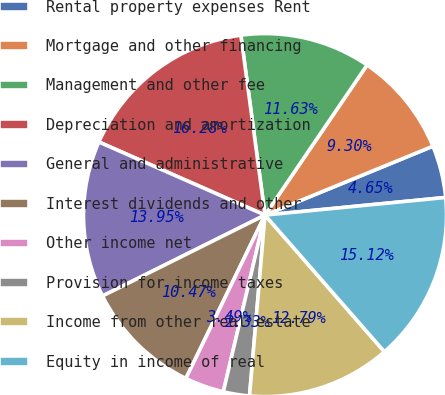<chart> <loc_0><loc_0><loc_500><loc_500><pie_chart><fcel>Rental property expenses Rent<fcel>Mortgage and other financing<fcel>Management and other fee<fcel>Depreciation and amortization<fcel>General and administrative<fcel>Interest dividends and other<fcel>Other income net<fcel>Provision for income taxes<fcel>Income from other real estate<fcel>Equity in income of real<nl><fcel>4.65%<fcel>9.3%<fcel>11.63%<fcel>16.28%<fcel>13.95%<fcel>10.47%<fcel>3.49%<fcel>2.33%<fcel>12.79%<fcel>15.12%<nl></chart> 